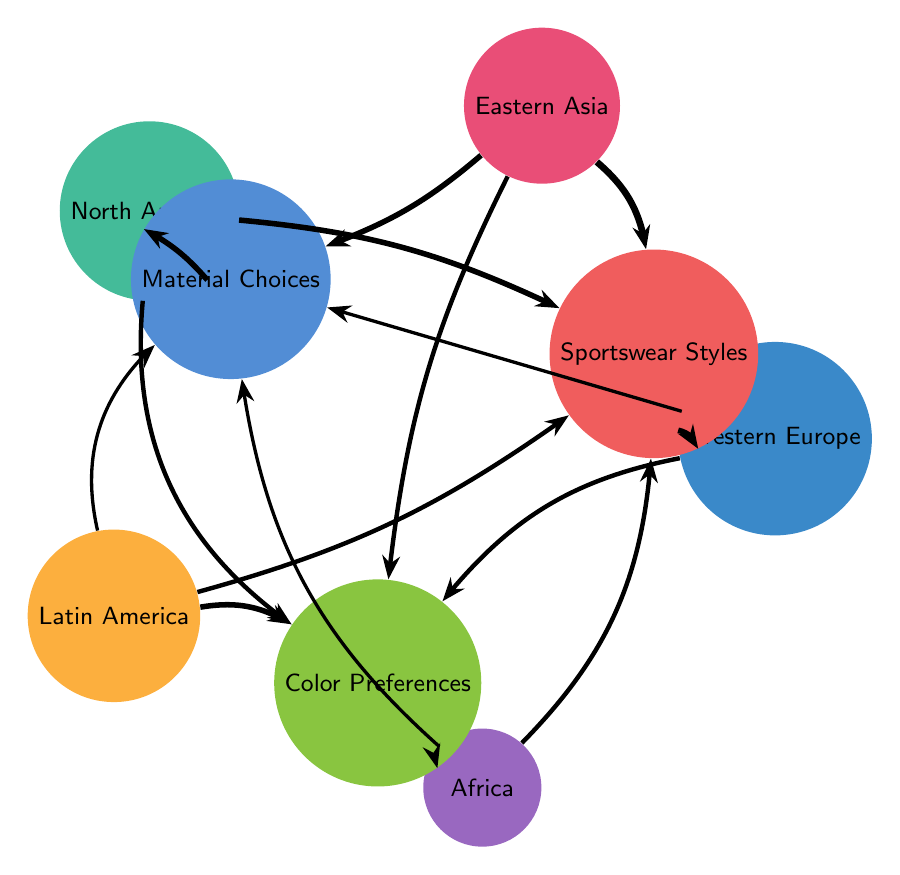What is the influence of Eastern Asia on Sportswear Styles? The diagram shows a link from Eastern Asia to Sportswear Styles with a value of 6, indicating a strong influence characterized by innovative and futuristic designs.
Answer: 6 Which region has a strong preference for vibrant colors in sportswear? The link from Latin America to Color Preferences has a value of 5, indicating that this region prefers bright and lively colors with tropical themes.
Answer: Latin America How many nodes are presented in the diagram? The diagram lists a total of 8 nodes, which include 5 regions and 3 cultural elements related to sportswear design.
Answer: 8 What is the influence of North America on Material Choices? The diagram indicates a link from North America to Material Choices with a value of 5, representing a strong influence focusing on performance-oriented synthetic materials.
Answer: 5 Which region exhibits minimalistic designs in sportswear? The arrow from Western Europe to Sportswear Styles mentions a value of 5, suggesting that this region’s designs are minimalistic with functional aesthetics.
Answer: Western Europe What color preferences are most common in Africa's sportswear designs? Looking at the link from Africa to Color Preferences, it has a value of 5 and indicates the use of rich and vibrant colors representing heritage.
Answer: Rich and vibrant colors What is the strongest influence on Material Choices? Among all regions, Eastern Asia shows the strongest influence on Material Choices with a value of 5, focusing on high-tech fabrics with advanced functionality.
Answer: Eastern Asia Which region's designs are characterized by bold prints? The diagram reveals that Africa influences sportswear styles with bold prints and traditional patterns, shown by the link with a value of 4.
Answer: Africa Which region shares a color preference similarity with Latin America? Both Latin America and Africa have a strong preference for vibrant colors, but Latin America highlights tropical themes while Africa emphasizes heritage, indicated by their values of 5.
Answer: Latin America and Africa 